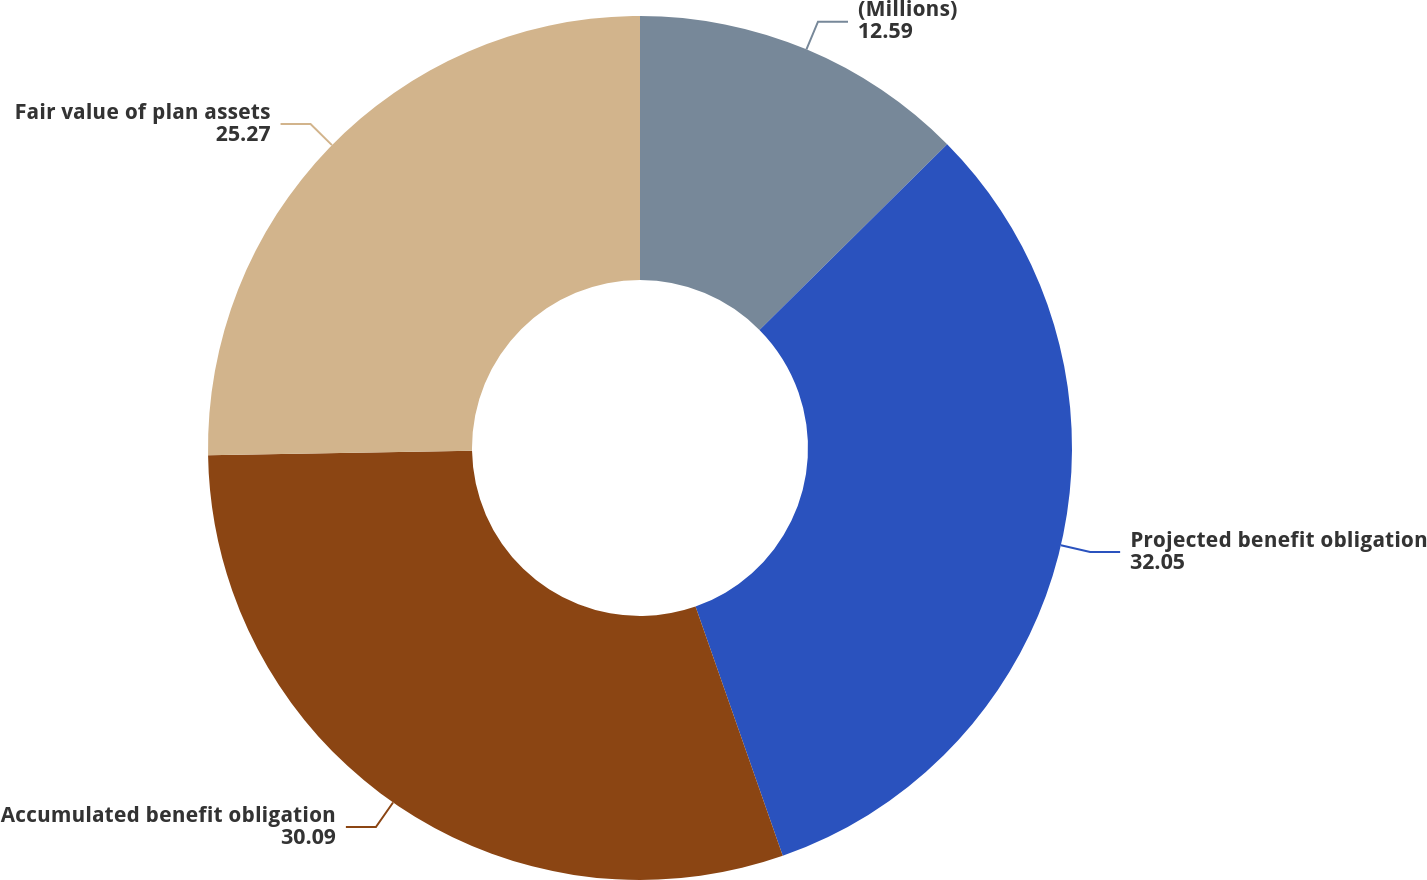Convert chart to OTSL. <chart><loc_0><loc_0><loc_500><loc_500><pie_chart><fcel>(Millions)<fcel>Projected benefit obligation<fcel>Accumulated benefit obligation<fcel>Fair value of plan assets<nl><fcel>12.59%<fcel>32.05%<fcel>30.09%<fcel>25.27%<nl></chart> 